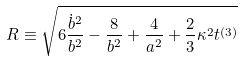<formula> <loc_0><loc_0><loc_500><loc_500>R \equiv \sqrt { 6 \frac { \dot { b } ^ { 2 } } { b ^ { 2 } } - \frac { 8 } { b ^ { 2 } } + \frac { 4 } { a ^ { 2 } } + \frac { 2 } { 3 } \kappa ^ { 2 } t ^ { \left ( 3 \right ) } }</formula> 